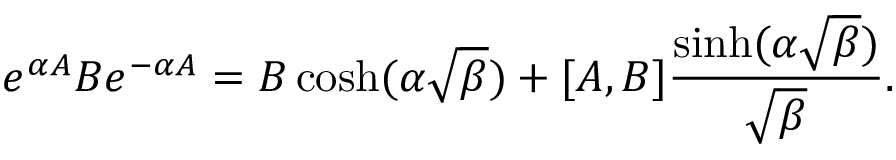Convert formula to latex. <formula><loc_0><loc_0><loc_500><loc_500>e ^ { \alpha A } B e ^ { - \alpha A } = B \cosh ( \alpha \sqrt { \beta } ) + [ A , B ] \frac { \sinh ( \alpha \sqrt { \beta } ) } { \sqrt { \beta } } .</formula> 